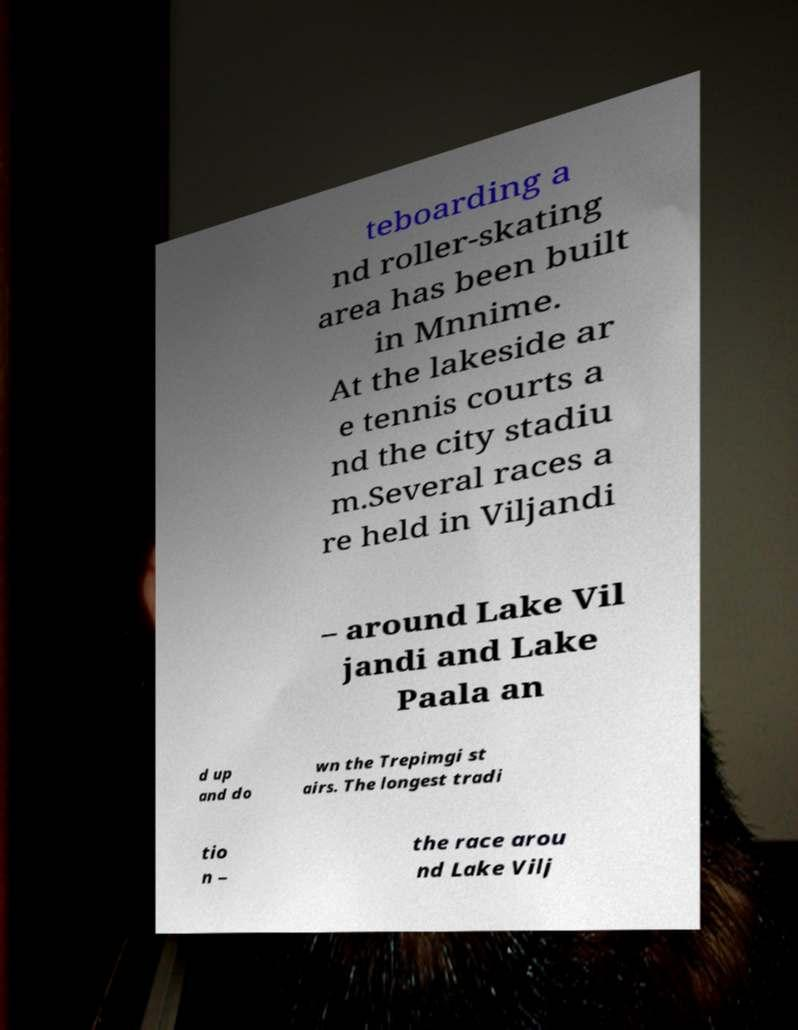What messages or text are displayed in this image? I need them in a readable, typed format. teboarding a nd roller-skating area has been built in Mnnime. At the lakeside ar e tennis courts a nd the city stadiu m.Several races a re held in Viljandi – around Lake Vil jandi and Lake Paala an d up and do wn the Trepimgi st airs. The longest tradi tio n – the race arou nd Lake Vilj 